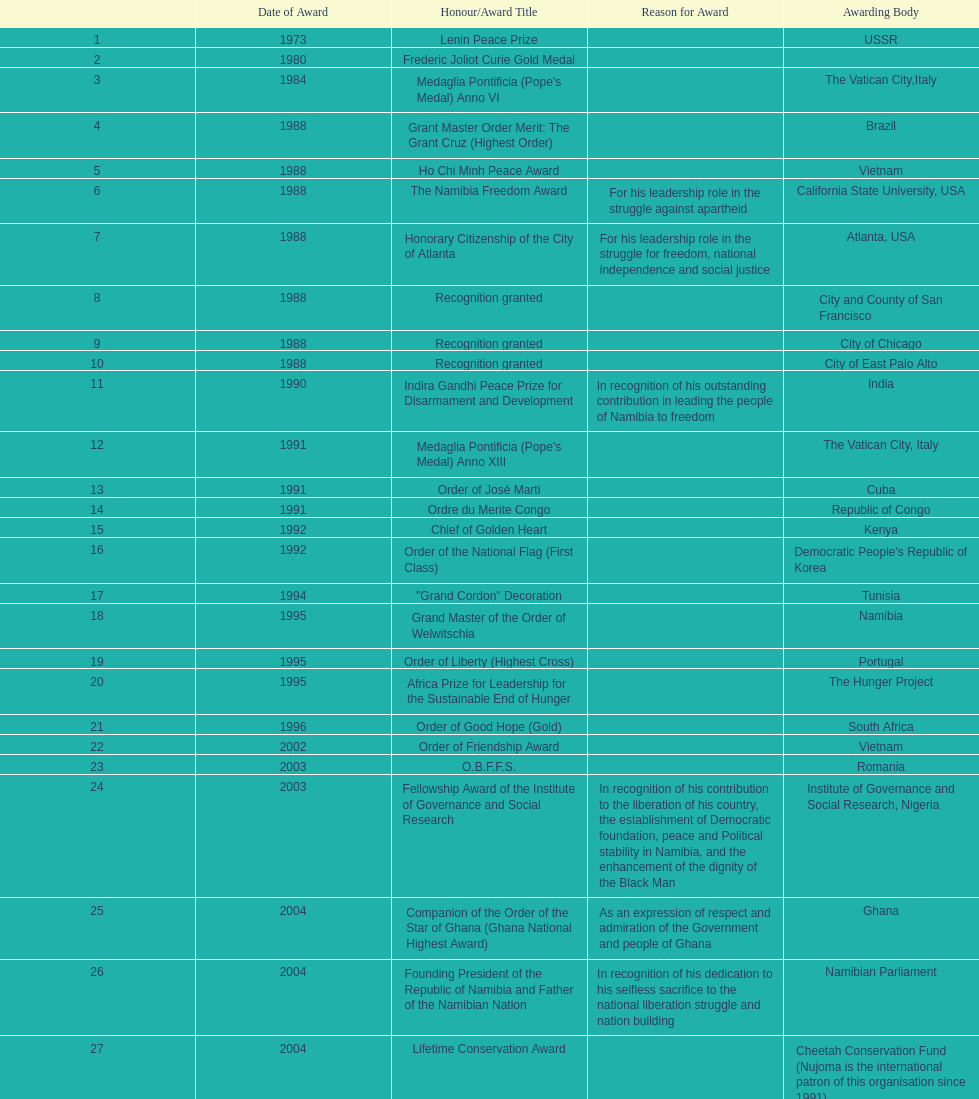What was the last award that nujoma won? Sir Seretse Khama SADC Meda. 